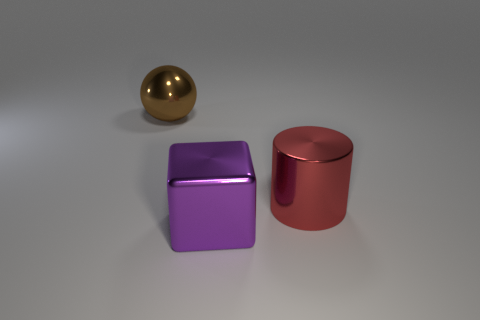Subtract all green cubes. Subtract all gray spheres. How many cubes are left? 1 Add 2 large metal spheres. How many objects exist? 5 Subtract all cubes. How many objects are left? 2 Add 3 large red objects. How many large red objects exist? 4 Subtract 0 green cubes. How many objects are left? 3 Subtract all big red shiny cylinders. Subtract all large brown things. How many objects are left? 1 Add 1 big red things. How many big red things are left? 2 